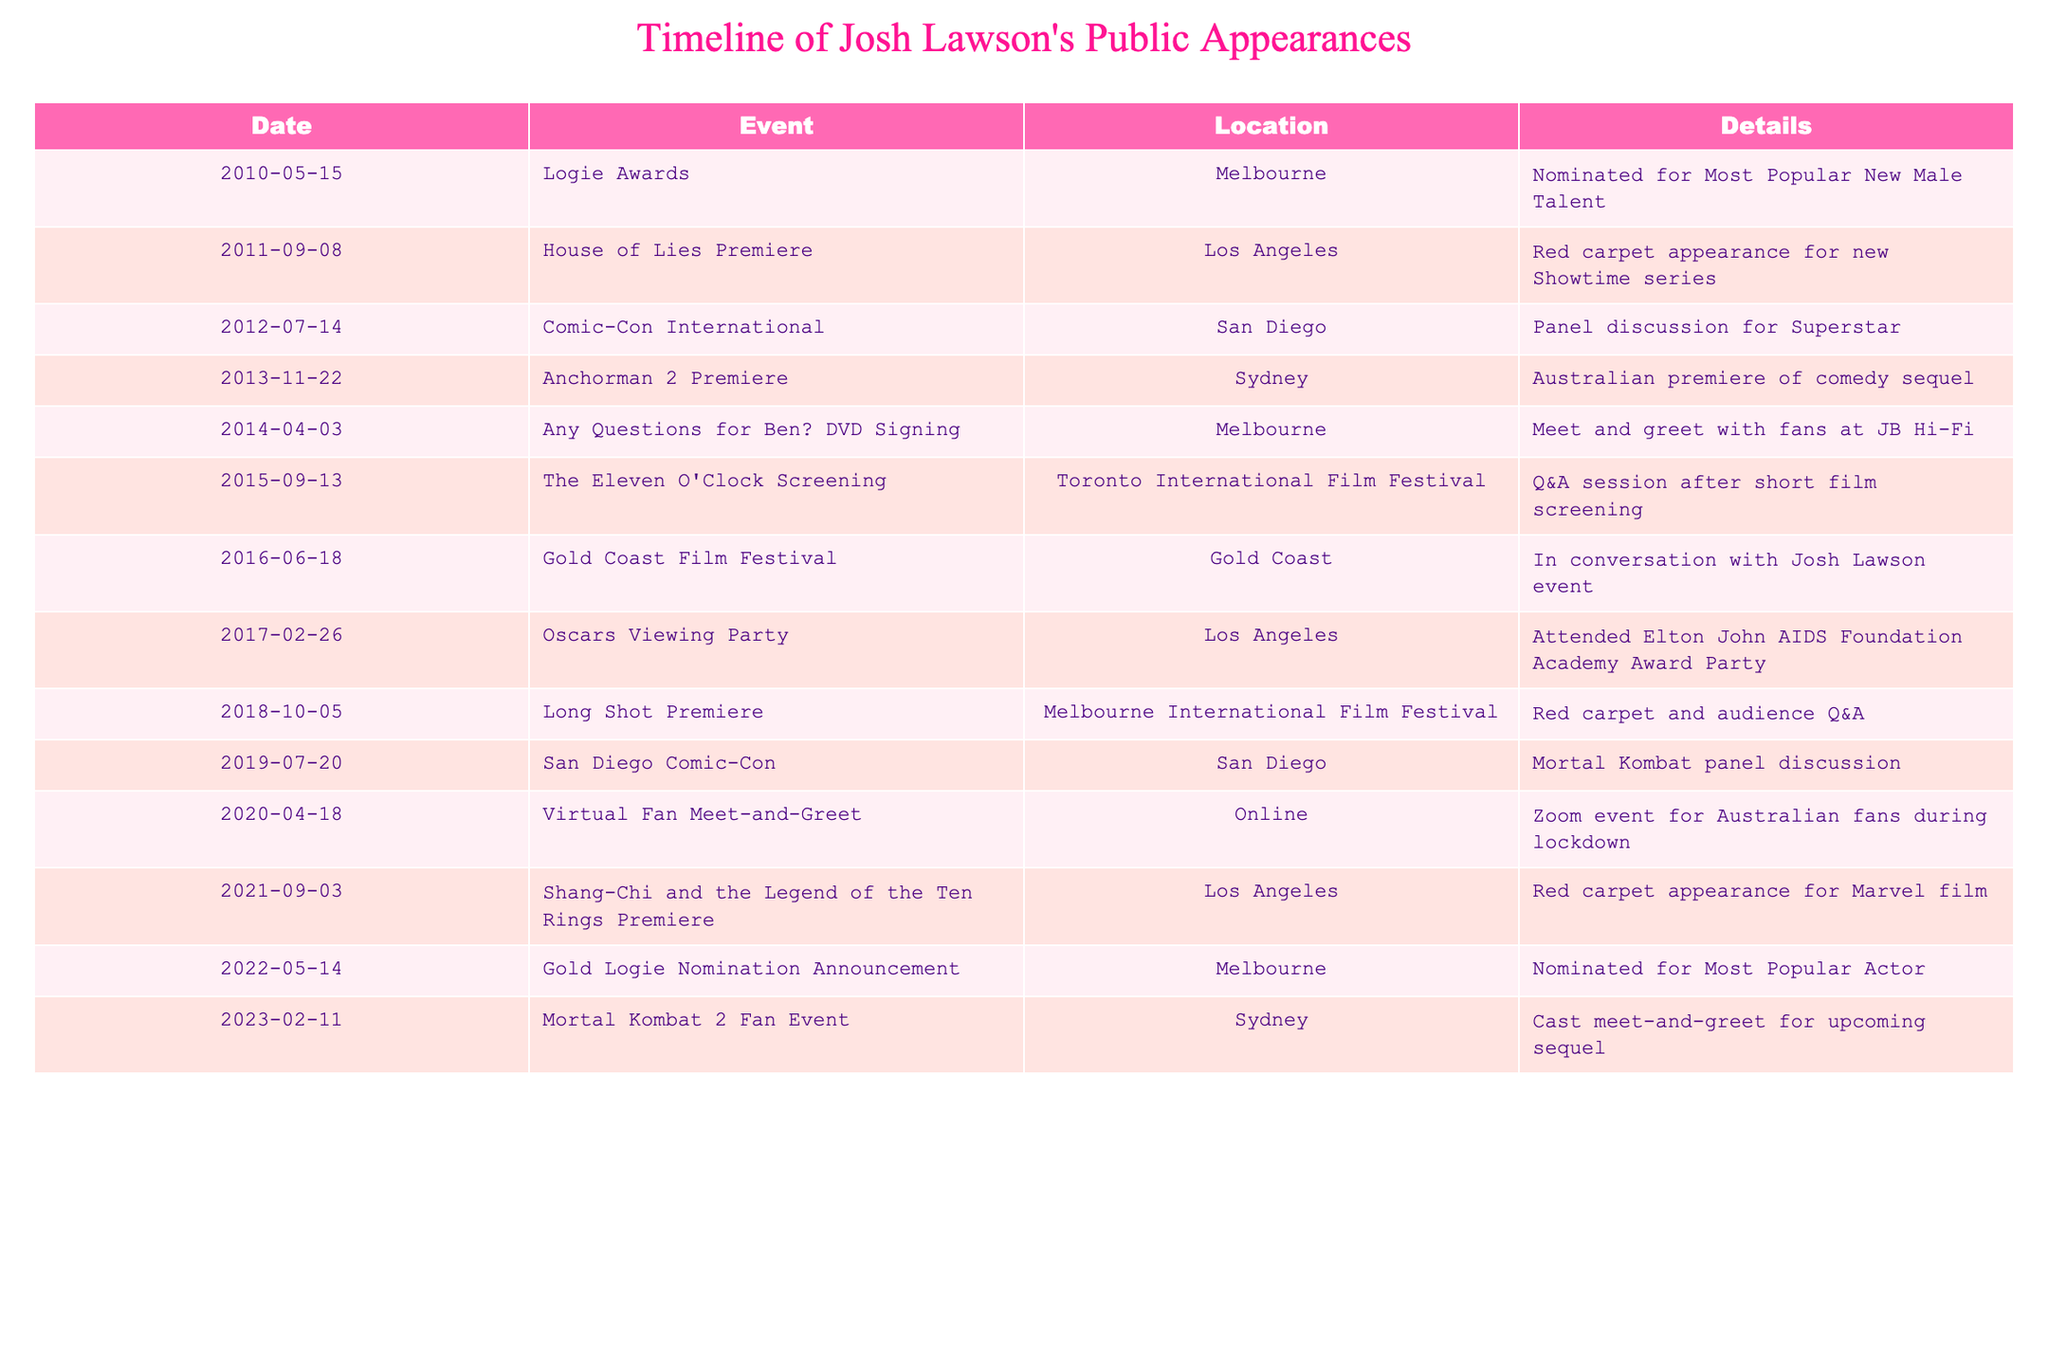What event did Josh Lawson attend in 2010? According to the table, on May 15, 2010, Josh Lawson attended the Logie Awards where he was nominated for Most Popular New Male Talent.
Answer: Logie Awards How many times did Josh Lawson appear at the San Diego Comic-Con? The table shows that Josh Lawson appeared at the San Diego Comic-Con twice: once on July 14, 2012, for a panel discussion regarding Superstar, and again on July 20, 2019, for a Mortal Kombat panel discussion. Thus, there are two appearances.
Answer: 2 Was Josh Lawson nominated for a Logie in 2022? The table indicates that on May 14, 2022, there was a Gold Logie nomination announcement, indicating he was nominated for Most Popular Actor. Therefore, the answer is yes.
Answer: Yes What was the first public appearance of Josh Lawson listed in the table? By reviewing the table, the first public appearance listed is the Logie Awards on May 15, 2010, where he was nominated for Most Popular New Male Talent.
Answer: Logie Awards How many events did Josh Lawson participate in during the year 2021? The table shows that in 2021, Josh Lawson appeared at one event, which was the Shang-Chi and the Legend of the Ten Rings Premiere on September 3, 2021. Therefore, the total count of events in that year is one.
Answer: 1 During which event did Josh Lawson have a Q&A session? Referring to the table, the event where Josh Lawson participated in a Q&A session was during The Eleven O'Clock Screening at the Toronto International Film Festival on September 13, 2015.
Answer: The Eleven O'Clock Screening What is the time span between Josh Lawson's first public appearance to the most recent one listed? The first appearance listed is from May 15, 2010, and the most recent one is from February 11, 2023. The time span between these two dates is approximately 12 years and 9 months. To confirm, count the total number of months: from May 2010 to February 2023, it accumulates to 153 months.
Answer: 12 years and 9 months Has Josh Lawson attended more events in Los Angeles or Melbourne? From the table, there are four events in Los Angeles: House of Lies Premiere, Oscars Viewing Party, Shang-Chi and the Legend of the Ten Rings Premiere. In Melbourne, there are three events: Logie Awards, Any Questions for Ben? DVD Signing, and Long Shot Premiere. Hence, Josh Lawson has attended more events in Los Angeles.
Answer: Los Angeles What type of event was held online during 2020? The table notes that on April 18, 2020, there was a Virtual Fan Meet-and-Greet conducted online via Zoom for Australian fans during lockdown. This specifies it as an online event.
Answer: Virtual Fan Meet-and-Greet 